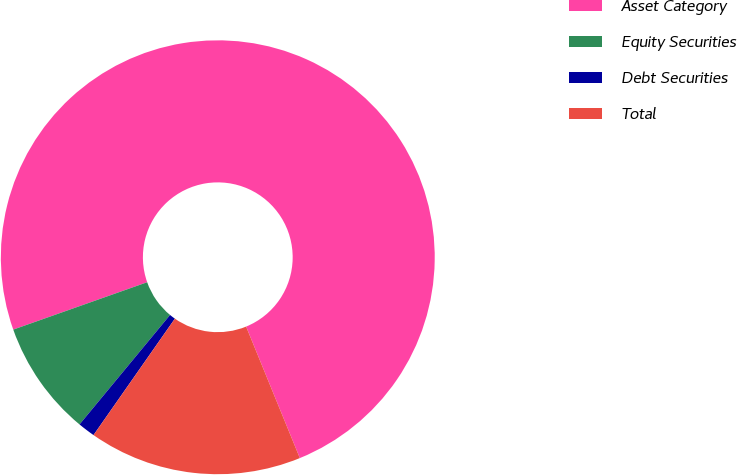Convert chart to OTSL. <chart><loc_0><loc_0><loc_500><loc_500><pie_chart><fcel>Asset Category<fcel>Equity Securities<fcel>Debt Securities<fcel>Total<nl><fcel>74.23%<fcel>8.59%<fcel>1.29%<fcel>15.88%<nl></chart> 